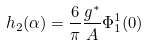<formula> <loc_0><loc_0><loc_500><loc_500>h _ { 2 } ( \alpha ) = \frac { 6 } { \pi } \frac { g ^ { * } } { A } \Phi ^ { 1 } _ { 1 } ( 0 )</formula> 